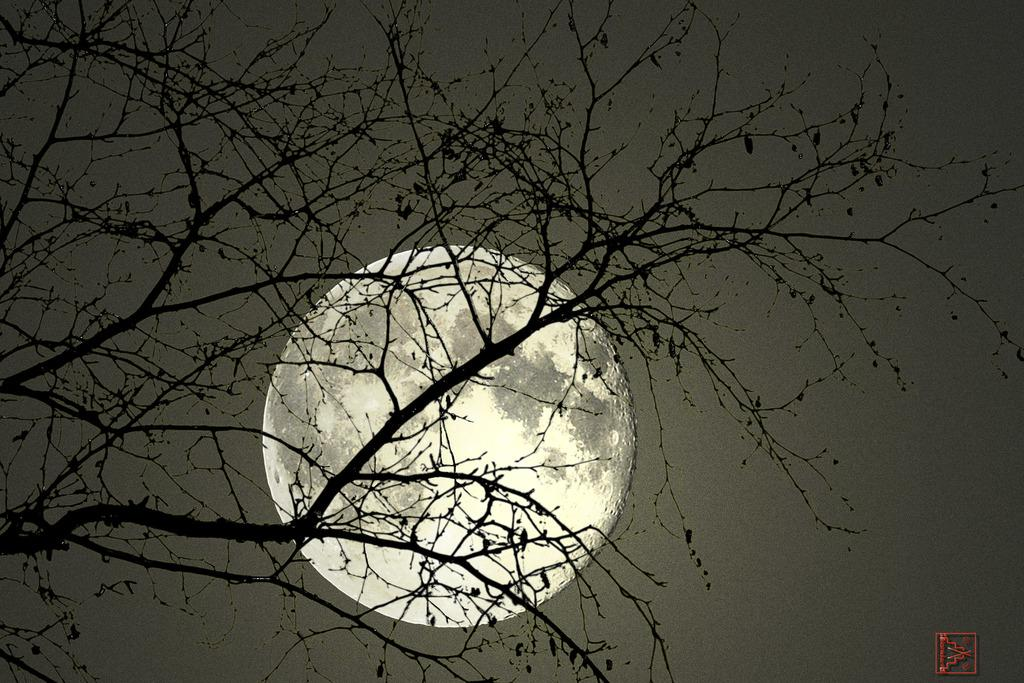What type of natural object can be seen in the image? There is a tree in the image. What celestial object is visible in the background of the image? The moon is visible in the background of the image. What else can be seen in the background of the image? The sky is visible in the background of the image. Where is the store located in the image? There is no store present in the image. Is there a crown visible on the tree in the image? There is no crown present on the tree in the image. 